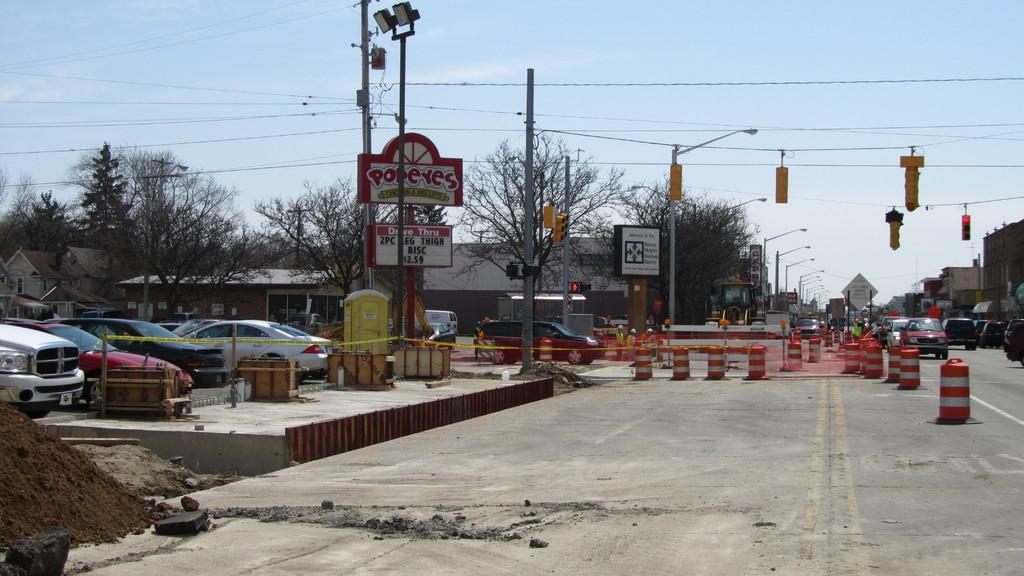<image>
Write a terse but informative summary of the picture. Red and white sign which says POPEYES in front of a building. 